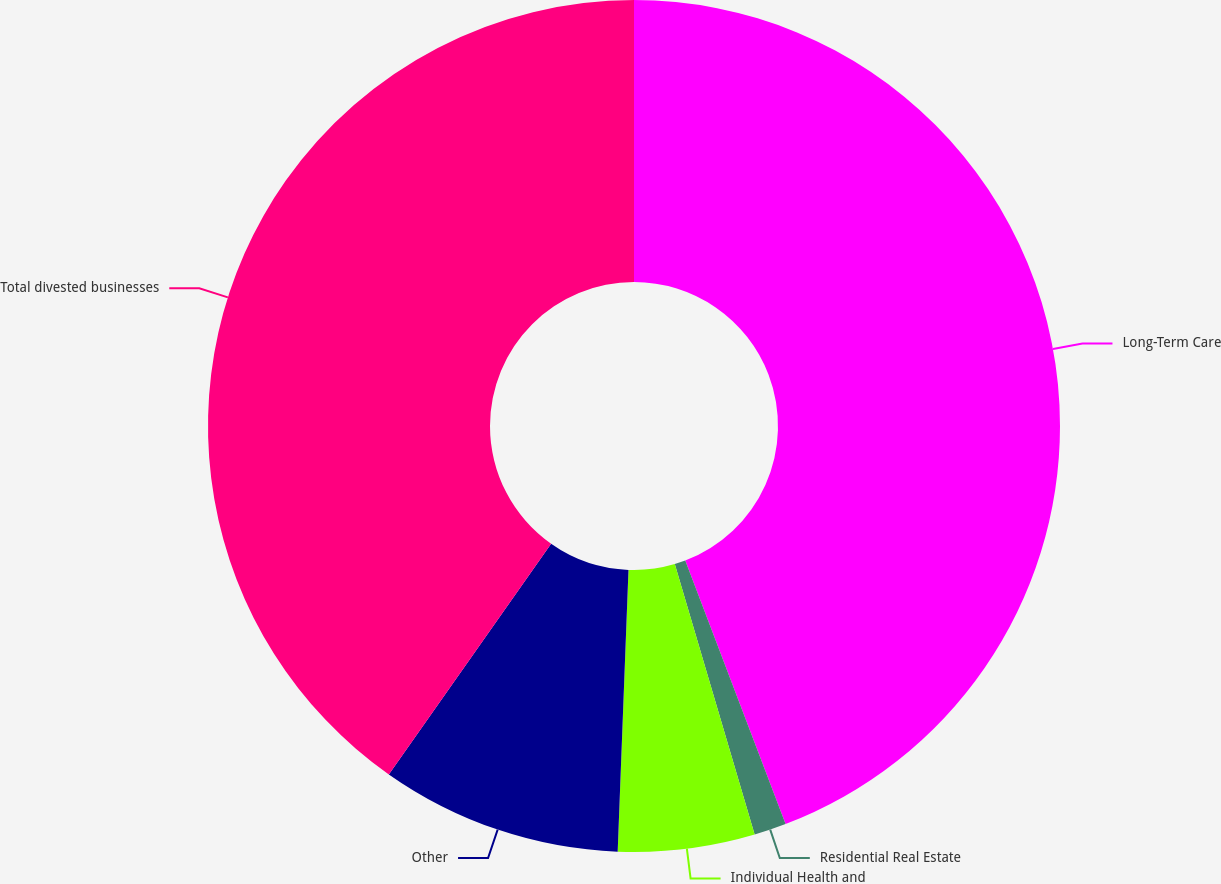Convert chart. <chart><loc_0><loc_0><loc_500><loc_500><pie_chart><fcel>Long-Term Care<fcel>Residential Real Estate<fcel>Individual Health and<fcel>Other<fcel>Total divested businesses<nl><fcel>44.21%<fcel>1.22%<fcel>5.18%<fcel>9.15%<fcel>40.24%<nl></chart> 